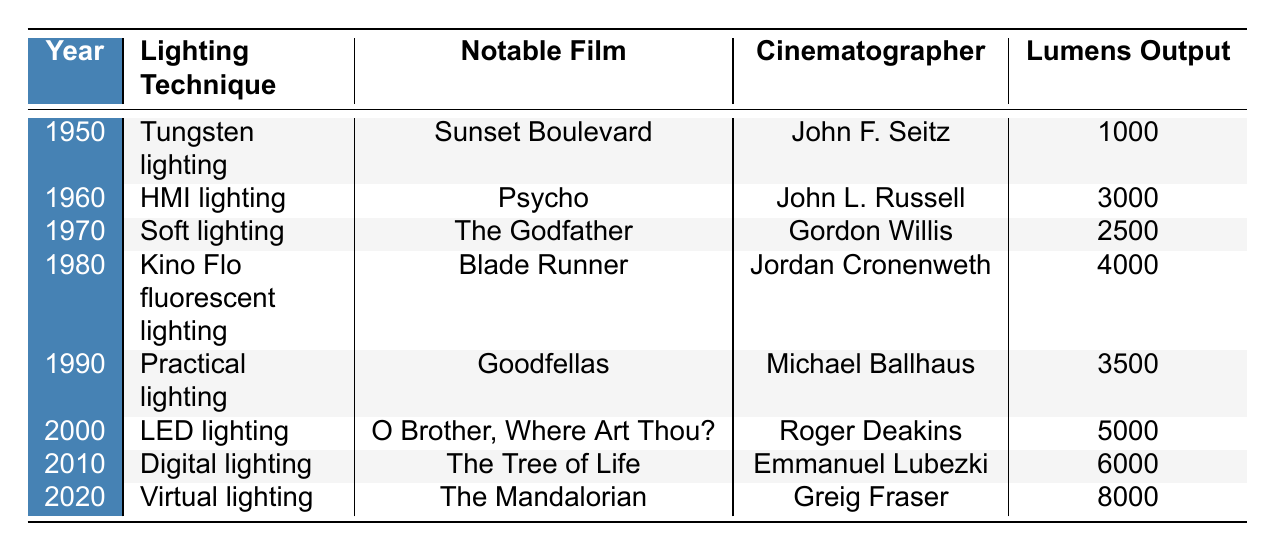What lighting technique was used in 1980? The table lists the lighting techniques by year, and for 1980, it shows "Kino Flo fluorescent lighting".
Answer: Kino Flo fluorescent lighting Which film featured the use of practical lighting? According to the table, practical lighting was used in "Goodfellas" in 1990.
Answer: Goodfellas What is the lumens output of the lighting technique used in 2000? For the year 2000, the table states that "LED lighting" had a lumens output of 5000.
Answer: 5000 Who was the cinematographer for "The Godfather"? The table indicates that Gordon Willis was the cinematographer for the film "The Godfather" released in 1970.
Answer: Gordon Willis Which lighting technique had the highest lumens output? The table shows that the technique with the highest lumens output is "Virtual lighting" from 2020, with an output of 8000 lumens.
Answer: Virtual lighting In what year did the use of soft lighting become notable? By examining the year associated with soft lighting in the table, it indicates that it became notable in 1970.
Answer: 1970 What was the difference in lumens output between the techniques used in 1990 and 2010? The lumens output in 1990 was 3500 and in 2010 it was 6000, so the difference is 6000 - 3500 = 2500.
Answer: 2500 Is it true that HMI lighting was used in a film directed by John L. Russell? Checking the table confirms that HMI lighting was indeed used in "Psycho", which was associated with cinematographer John L. Russell in 1960, making the statement true.
Answer: True What was the trend in lumens output from 1950 to 2020? Analyzing the lumens outputs from the table, they increased from 1000 in 1950 to 8000 in 2020, indicating an upward trend over the years.
Answer: Upward trend Which cinematographer had the earliest notable lighting technique listed? Looking at the earliest year in the table, John F. Seitz used tungsten lighting for "Sunset Boulevard" in 1950, making him the first listed.
Answer: John F. Seitz 